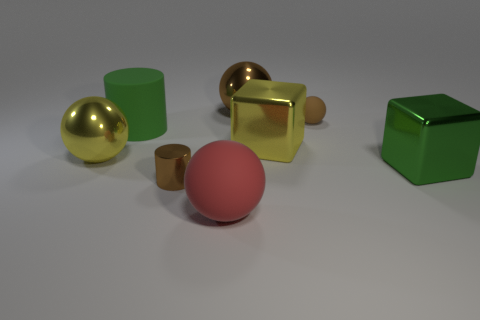Subtract all tiny rubber balls. How many balls are left? 3 Subtract all brown cylinders. How many cylinders are left? 1 Subtract 0 purple cubes. How many objects are left? 8 Subtract all cylinders. How many objects are left? 6 Subtract 1 blocks. How many blocks are left? 1 Subtract all green spheres. Subtract all green blocks. How many spheres are left? 4 Subtract all red cylinders. How many brown spheres are left? 2 Subtract all cubes. Subtract all red matte objects. How many objects are left? 5 Add 1 shiny things. How many shiny things are left? 6 Add 3 balls. How many balls exist? 7 